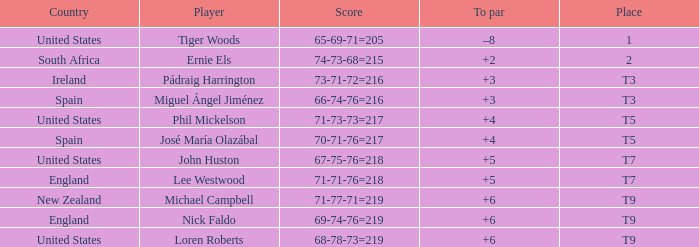What is To Par, when Place is "T5", and when Country is "United States"? 4.0. 